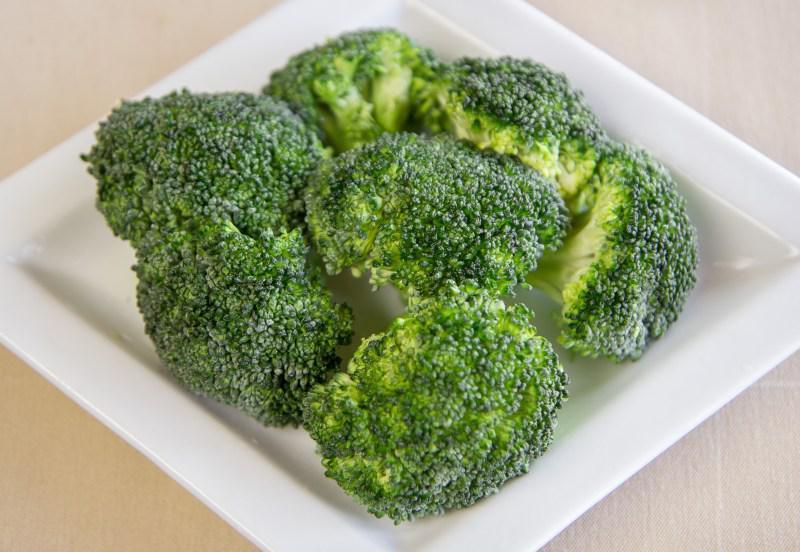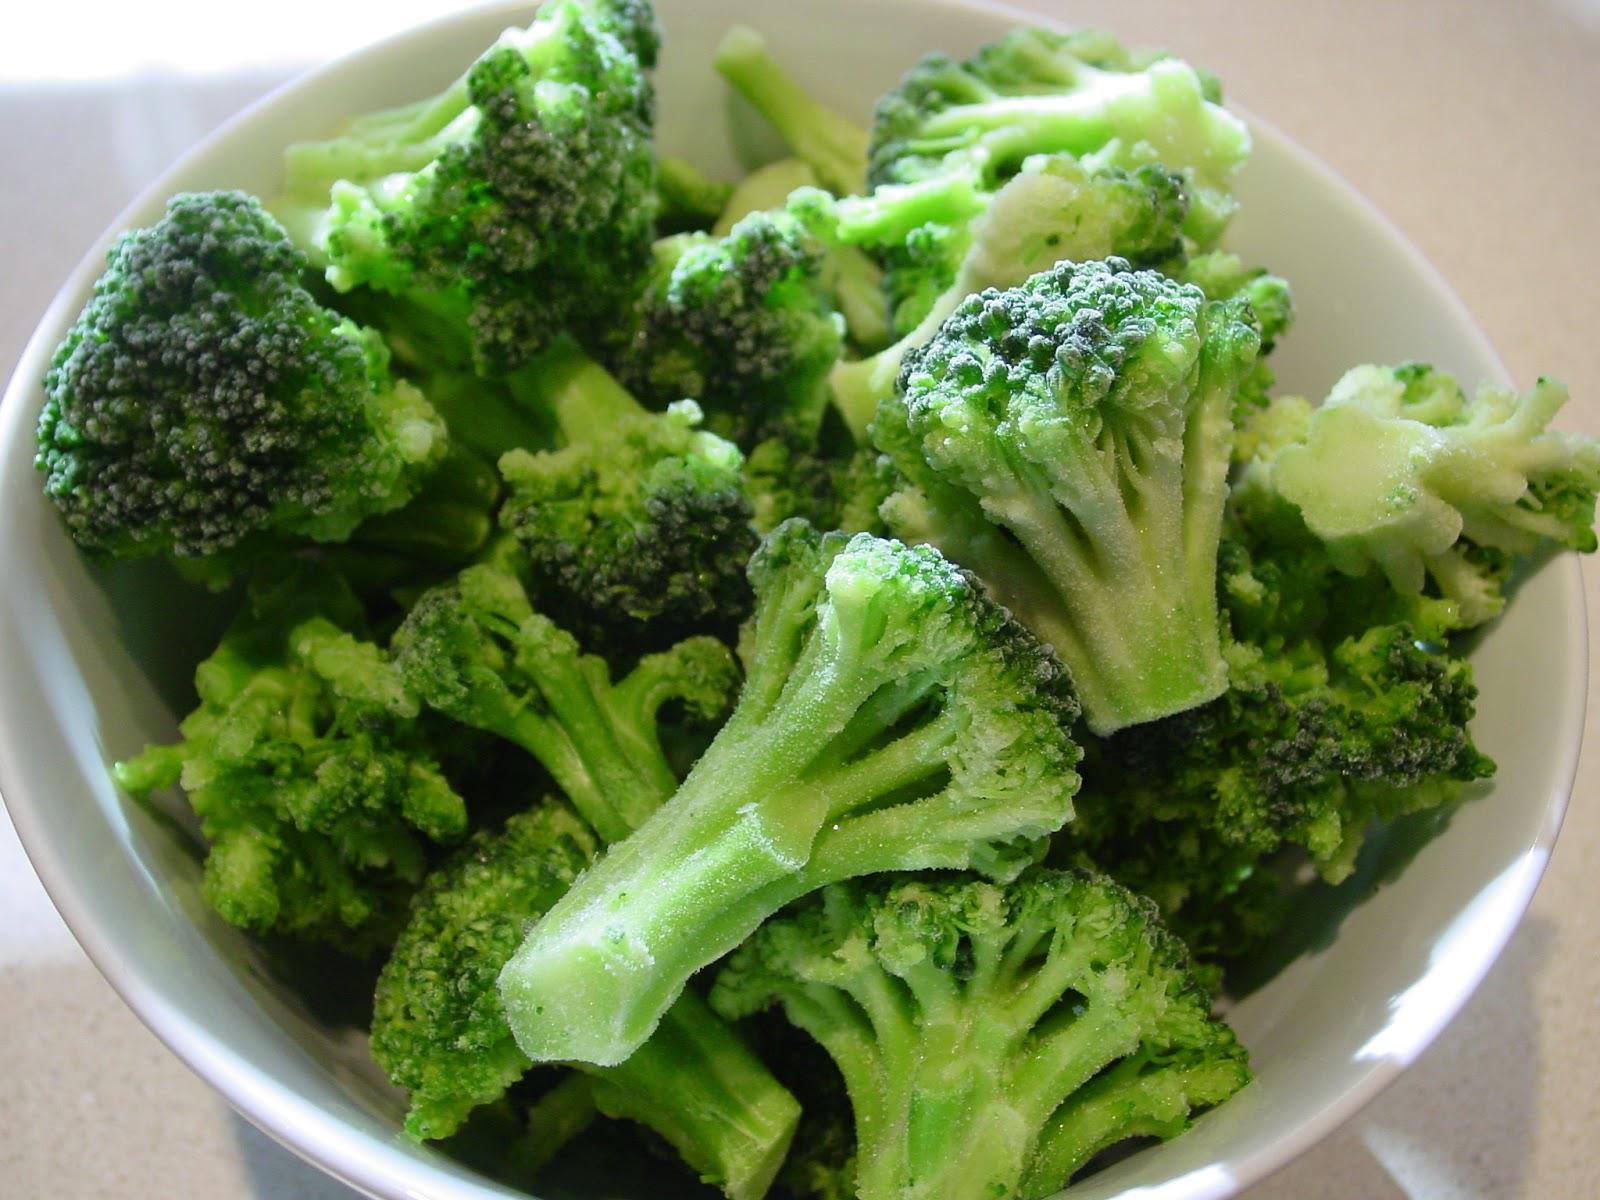The first image is the image on the left, the second image is the image on the right. Given the left and right images, does the statement "An image shows broccoli in a white container with a handle." hold true? Answer yes or no. No. The first image is the image on the left, the second image is the image on the right. Analyze the images presented: Is the assertion "No dish is visible in the left image." valid? Answer yes or no. No. 